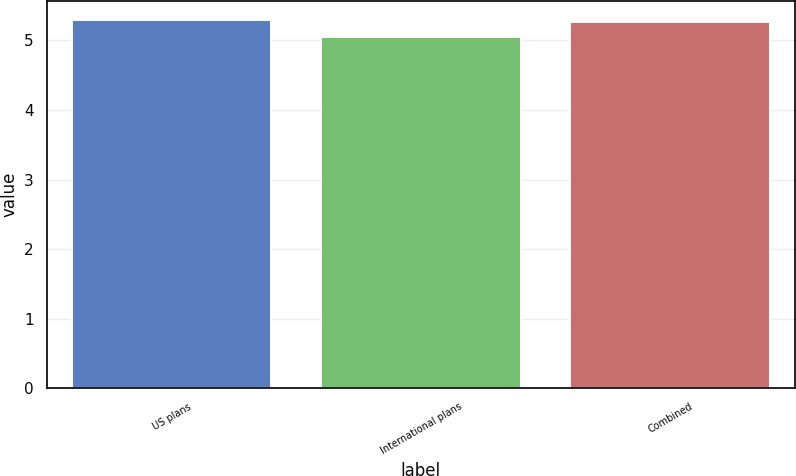Convert chart to OTSL. <chart><loc_0><loc_0><loc_500><loc_500><bar_chart><fcel>US plans<fcel>International plans<fcel>Combined<nl><fcel>5.3<fcel>5.05<fcel>5.26<nl></chart> 